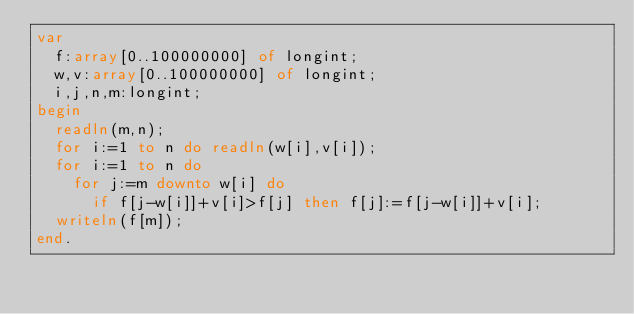<code> <loc_0><loc_0><loc_500><loc_500><_Pascal_>var
  f:array[0..100000000] of longint;
  w,v:array[0..100000000] of longint;
  i,j,n,m:longint;
begin
  readln(m,n);
  for i:=1 to n do readln(w[i],v[i]);
  for i:=1 to n do
    for j:=m downto w[i] do
      if f[j-w[i]]+v[i]>f[j] then f[j]:=f[j-w[i]]+v[i];
  writeln(f[m]);
end.</code> 